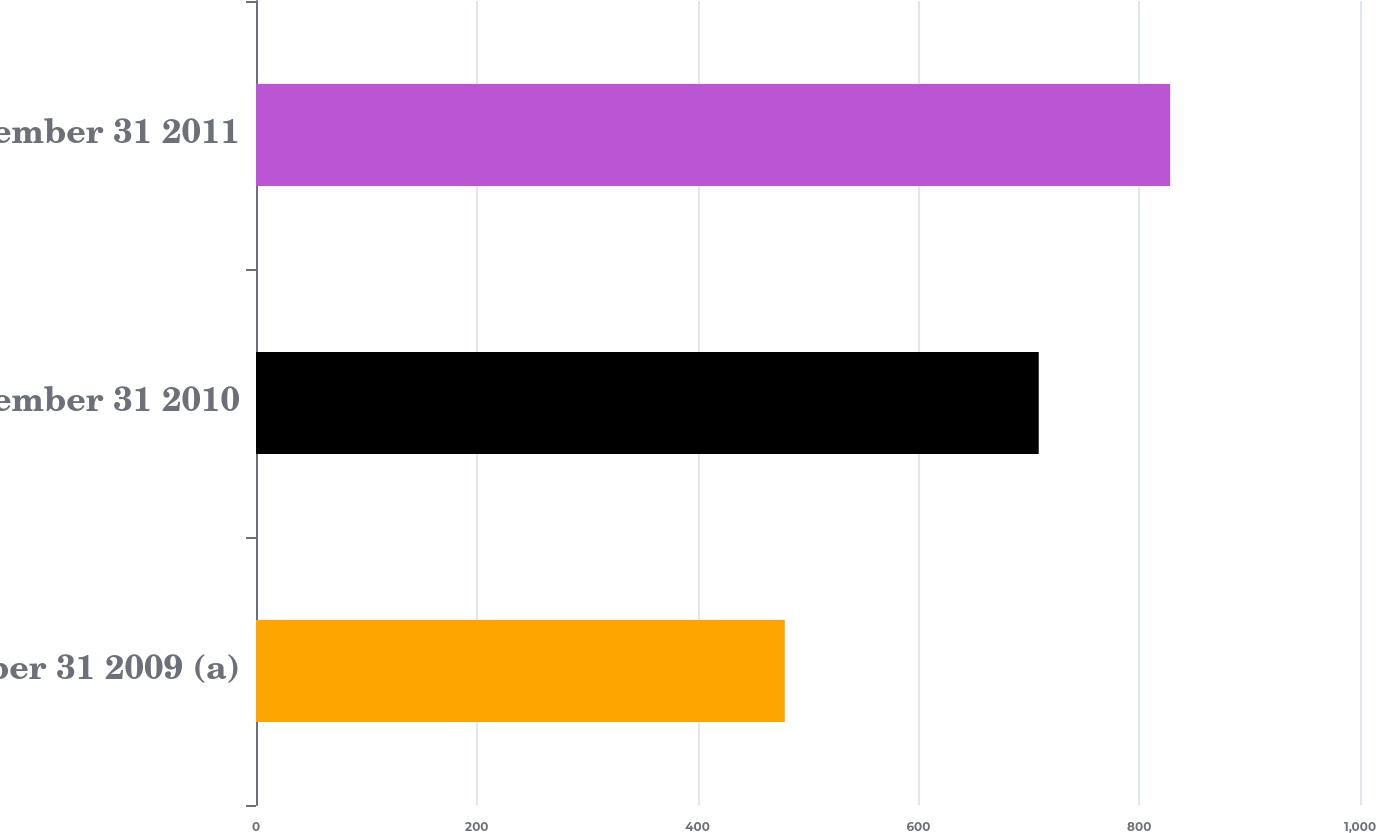Convert chart to OTSL. <chart><loc_0><loc_0><loc_500><loc_500><bar_chart><fcel>December 31 2009 (a)<fcel>December 31 2010<fcel>December 31 2011<nl><fcel>479<fcel>709<fcel>828<nl></chart> 